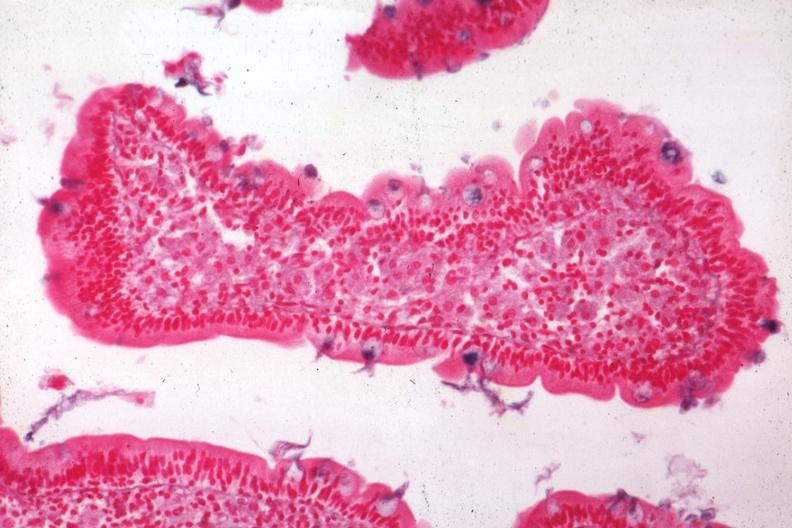s autopsy present?
Answer the question using a single word or phrase. No 